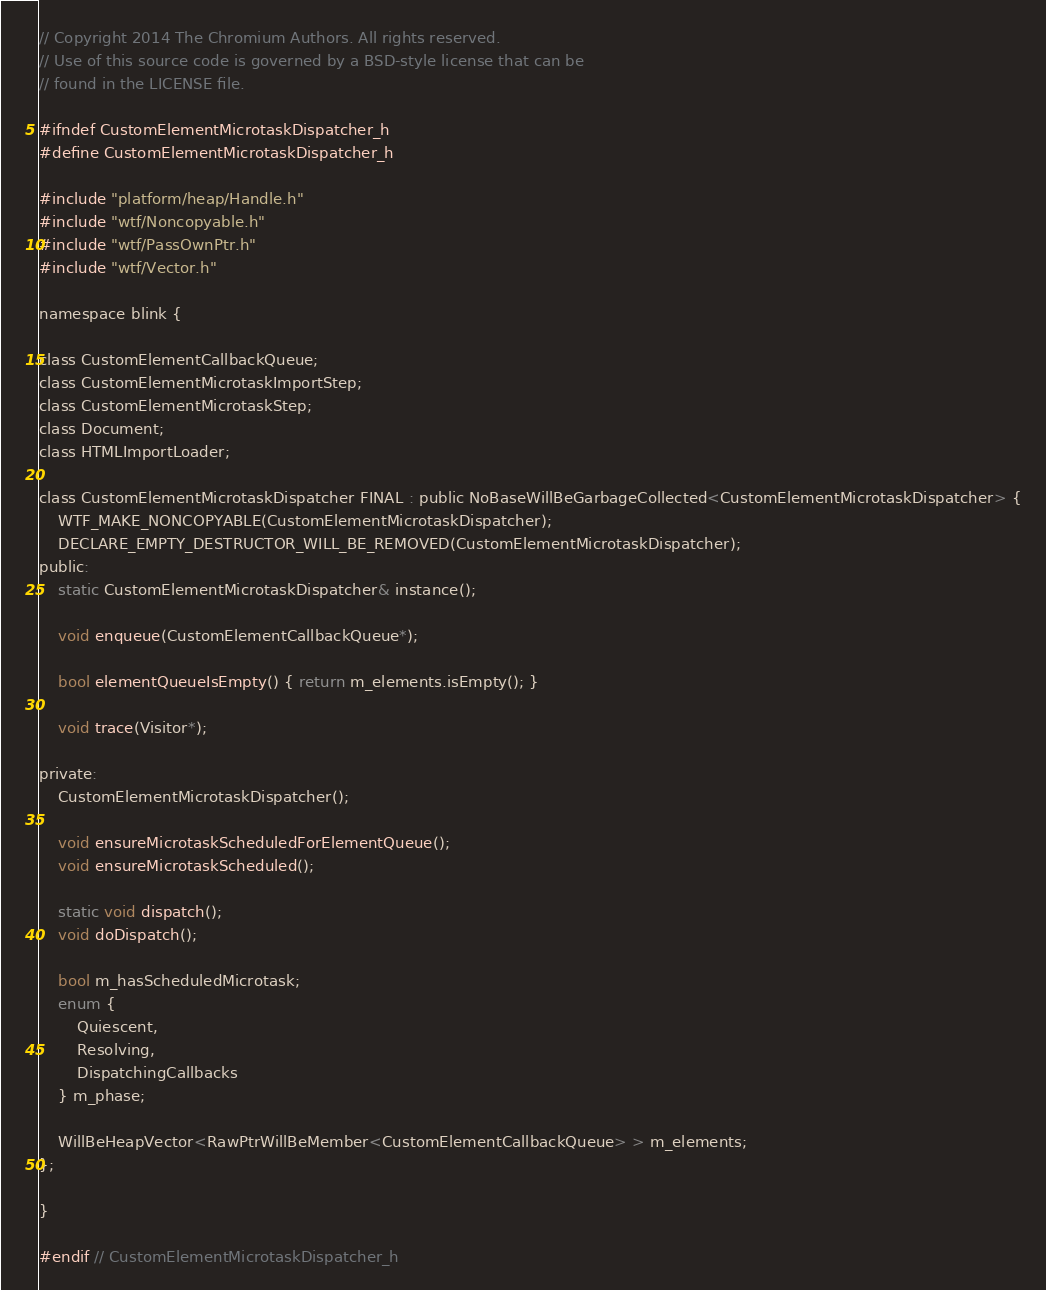Convert code to text. <code><loc_0><loc_0><loc_500><loc_500><_C_>// Copyright 2014 The Chromium Authors. All rights reserved.
// Use of this source code is governed by a BSD-style license that can be
// found in the LICENSE file.

#ifndef CustomElementMicrotaskDispatcher_h
#define CustomElementMicrotaskDispatcher_h

#include "platform/heap/Handle.h"
#include "wtf/Noncopyable.h"
#include "wtf/PassOwnPtr.h"
#include "wtf/Vector.h"

namespace blink {

class CustomElementCallbackQueue;
class CustomElementMicrotaskImportStep;
class CustomElementMicrotaskStep;
class Document;
class HTMLImportLoader;

class CustomElementMicrotaskDispatcher FINAL : public NoBaseWillBeGarbageCollected<CustomElementMicrotaskDispatcher> {
    WTF_MAKE_NONCOPYABLE(CustomElementMicrotaskDispatcher);
    DECLARE_EMPTY_DESTRUCTOR_WILL_BE_REMOVED(CustomElementMicrotaskDispatcher);
public:
    static CustomElementMicrotaskDispatcher& instance();

    void enqueue(CustomElementCallbackQueue*);

    bool elementQueueIsEmpty() { return m_elements.isEmpty(); }

    void trace(Visitor*);

private:
    CustomElementMicrotaskDispatcher();

    void ensureMicrotaskScheduledForElementQueue();
    void ensureMicrotaskScheduled();

    static void dispatch();
    void doDispatch();

    bool m_hasScheduledMicrotask;
    enum {
        Quiescent,
        Resolving,
        DispatchingCallbacks
    } m_phase;

    WillBeHeapVector<RawPtrWillBeMember<CustomElementCallbackQueue> > m_elements;
};

}

#endif // CustomElementMicrotaskDispatcher_h
</code> 